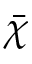<formula> <loc_0><loc_0><loc_500><loc_500>\bar { \chi }</formula> 